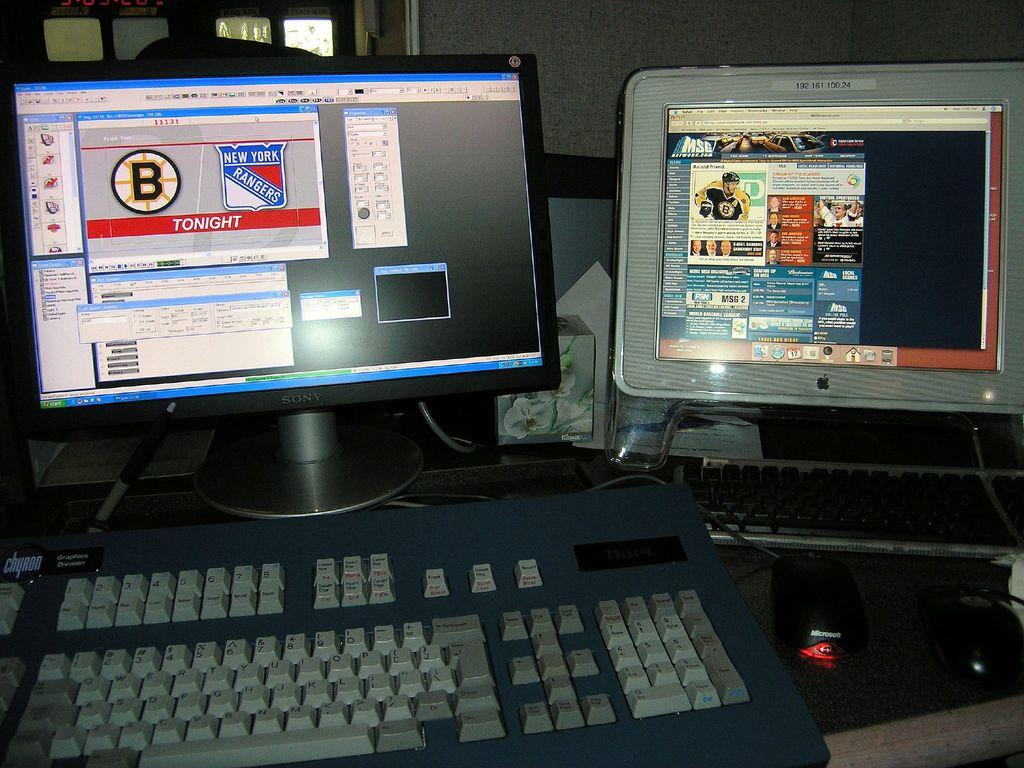Provide a one-sentence caption for the provided image. A computer monitor displays information related to the New York Rangers. 